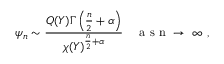Convert formula to latex. <formula><loc_0><loc_0><loc_500><loc_500>\psi _ { n } \sim \frac { Q ( Y ) \Gamma \left ( \frac { n } { 2 } + \alpha \right ) } { \chi ( Y ) ^ { \frac { n } { 2 } + \alpha } } \quad a s n \to \infty ,</formula> 